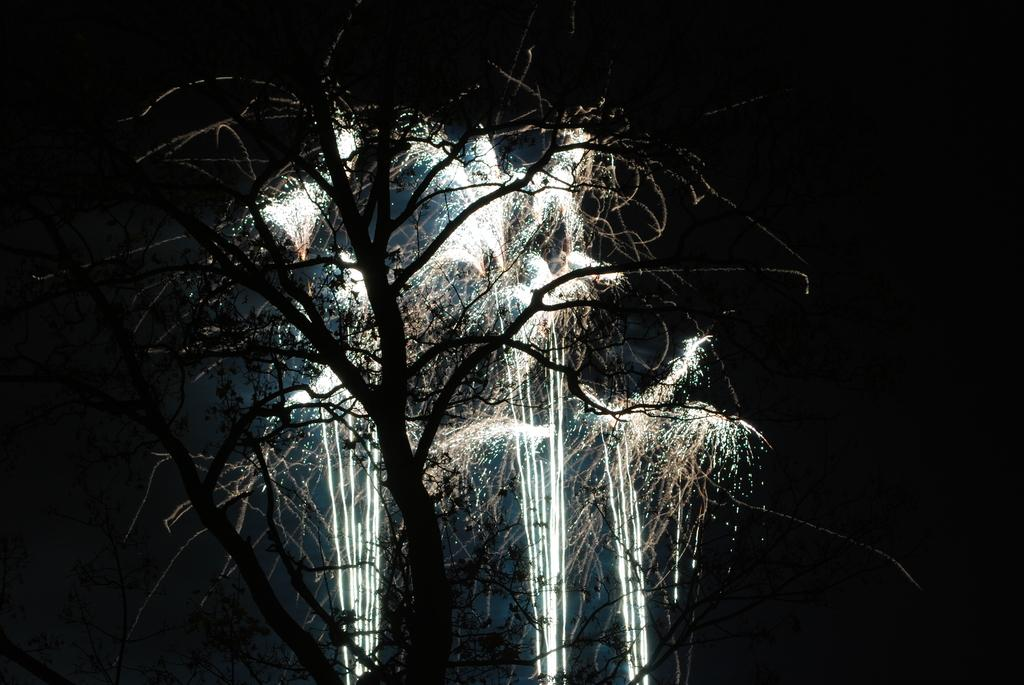What type of vegetation can be seen in the image? There are trees in the image. What else is present in the image besides trees? There are lights in the image. Where are the trees and lights located in the image? The trees and lights are located in the middle of the image. What type of stick can be seen in the image? There is no stick present in the image. Is the image depicting a camp scene? The image does not show any camp-related elements, so it cannot be determined if it is depicting a camp scene. 